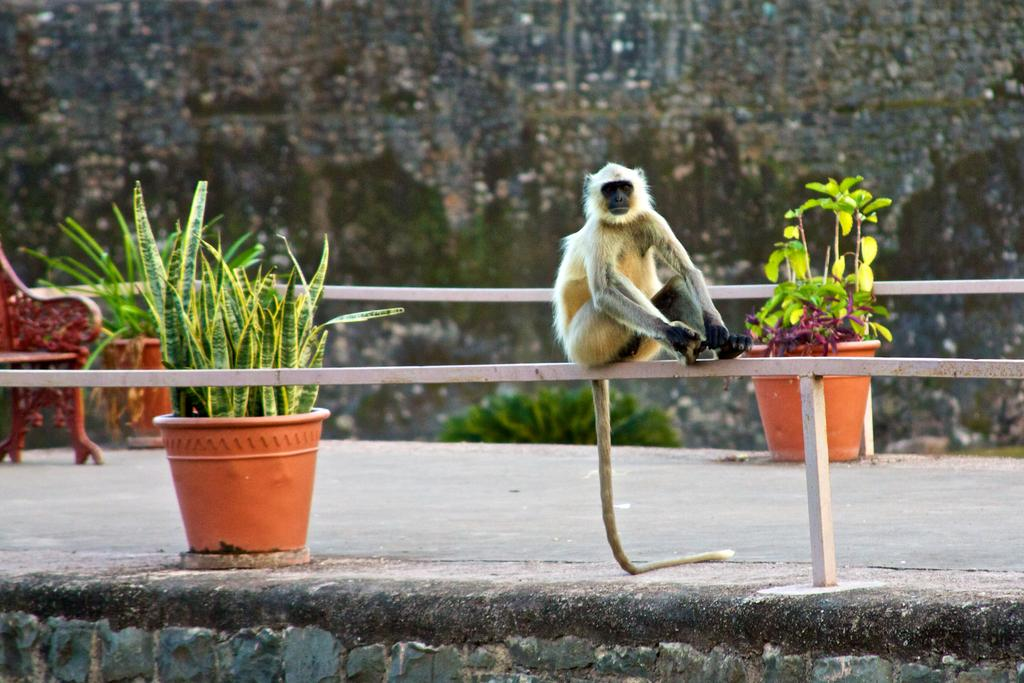What animal is present in the image? There is a monkey in the image. Where is the monkey sitting? The monkey is sitting on an iron rod. What can be seen behind the monkey? There are pots with plants behind the monkey. What type of seating is visible in the image? There is a bench in the image. What is the background of the image made of? There is a wall in the image. What type of sign can be seen hanging from the wall in the image? There is no sign present in the image; only a monkey, iron rod, pots with plants, bench, and wall are visible. 